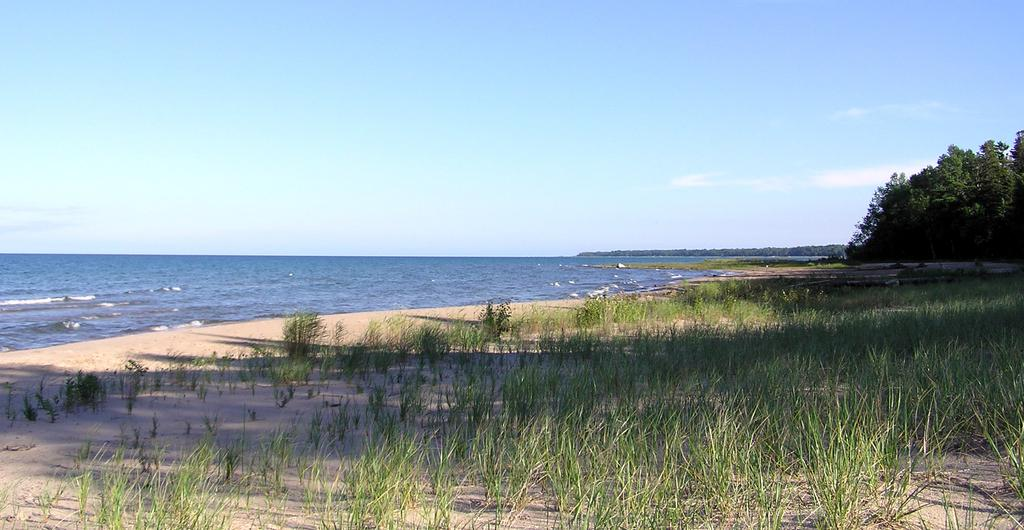What type of natural feature is located towards the left side of the image? There is an ocean towards the left side of the image. What type of natural feature is located towards the right side of the image? There is a land with grass towards the right side of the image. What type of vegetation can be seen in the right corner of the image? There are trees in the right corner of the image. What is visible at the top of the image? The sky is visible at the top of the image. How much debt is represented by the trees in the image? There is no representation of debt in the image; it features an ocean, land with grass, trees, and the sky. 